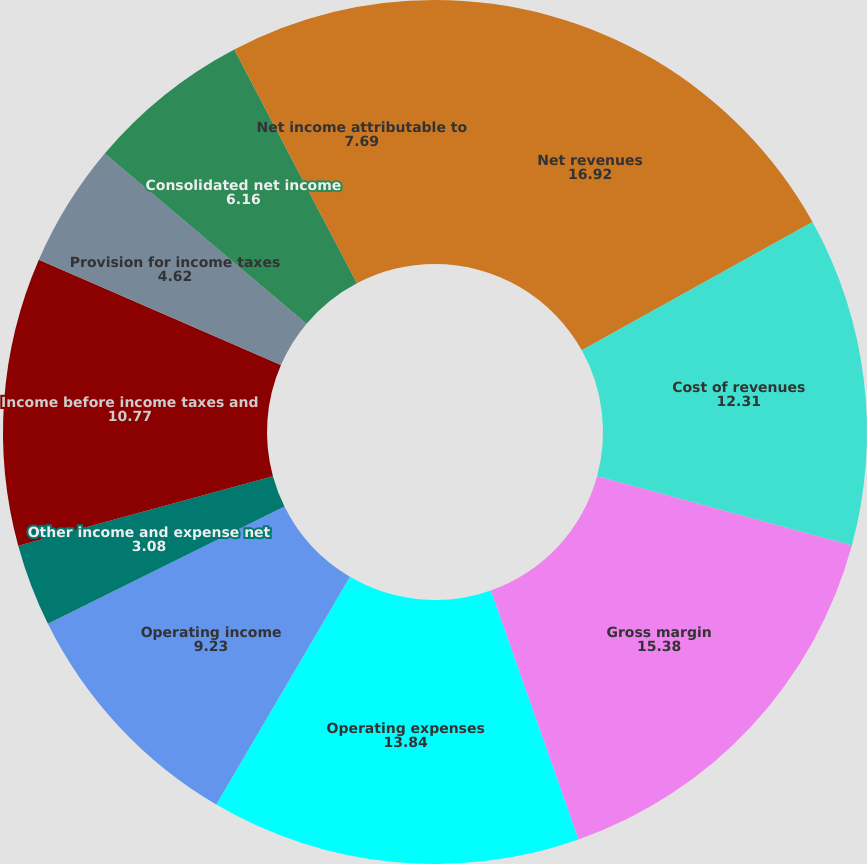<chart> <loc_0><loc_0><loc_500><loc_500><pie_chart><fcel>Net revenues<fcel>Cost of revenues<fcel>Gross margin<fcel>Operating expenses<fcel>Operating income<fcel>Other income and expense net<fcel>Income before income taxes and<fcel>Provision for income taxes<fcel>Consolidated net income<fcel>Net income attributable to<nl><fcel>16.92%<fcel>12.31%<fcel>15.38%<fcel>13.84%<fcel>9.23%<fcel>3.08%<fcel>10.77%<fcel>4.62%<fcel>6.16%<fcel>7.69%<nl></chart> 